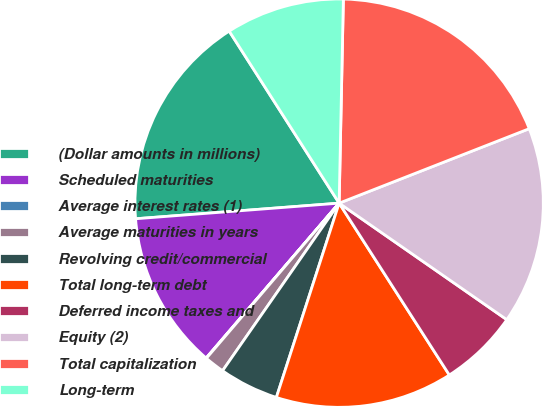Convert chart to OTSL. <chart><loc_0><loc_0><loc_500><loc_500><pie_chart><fcel>(Dollar amounts in millions)<fcel>Scheduled maturities<fcel>Average interest rates (1)<fcel>Average maturities in years<fcel>Revolving credit/commercial<fcel>Total long-term debt<fcel>Deferred income taxes and<fcel>Equity (2)<fcel>Total capitalization<fcel>Long-term<nl><fcel>17.17%<fcel>12.49%<fcel>0.03%<fcel>1.59%<fcel>4.7%<fcel>14.05%<fcel>6.26%<fcel>15.61%<fcel>18.73%<fcel>9.38%<nl></chart> 